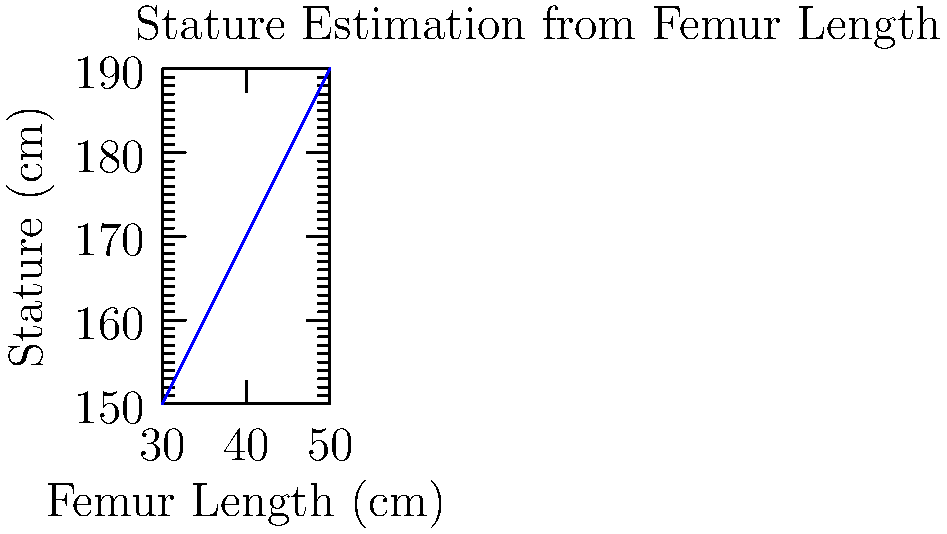Using the regression formula for stature estimation from femur length: Stature (cm) = 2.32 × Femur Length (cm) + 65.53, calculate the estimated stature for an individual with a femur length of 43 cm. Round your answer to the nearest centimeter. To estimate the stature using the given regression formula, we follow these steps:

1. Identify the formula:
   Stature (cm) = 2.32 × Femur Length (cm) + 65.53

2. Insert the given femur length (43 cm) into the formula:
   Stature (cm) = 2.32 × 43 + 65.53

3. Calculate the multiplication:
   Stature (cm) = 99.76 + 65.53

4. Perform the addition:
   Stature (cm) = 165.29

5. Round to the nearest centimeter:
   Stature (cm) ≈ 165 cm

The estimated stature for an individual with a femur length of 43 cm is 165 cm.
Answer: 165 cm 